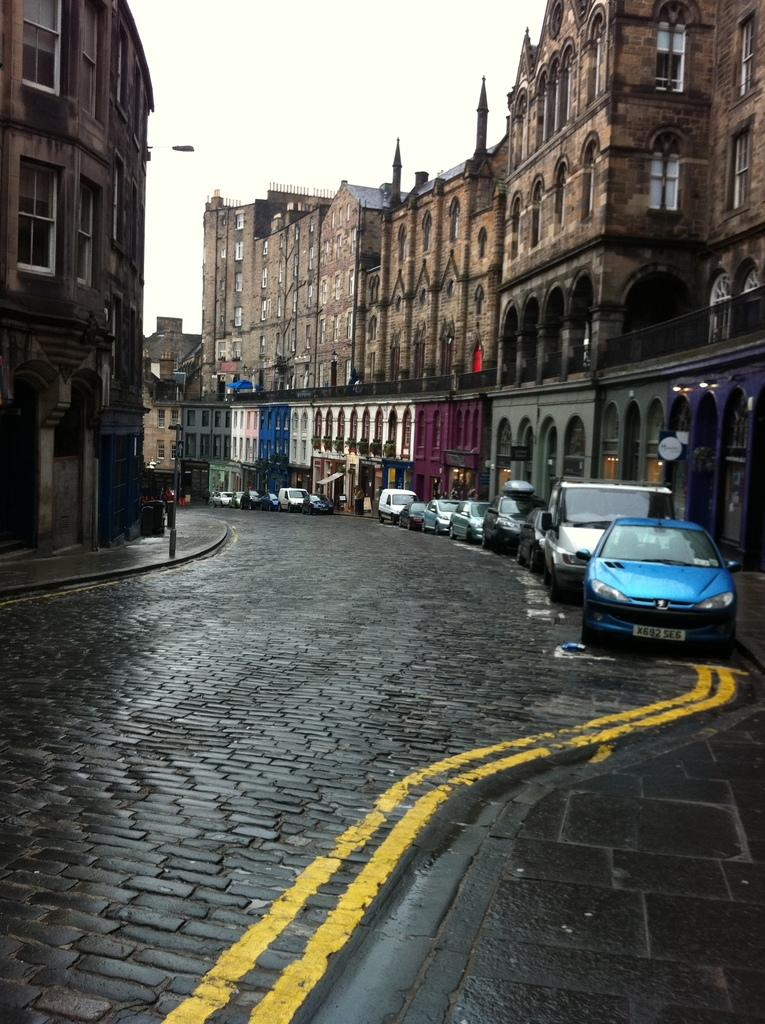<image>
Render a clear and concise summary of the photo. The first blue car on this street has the registration X692 SE6. 